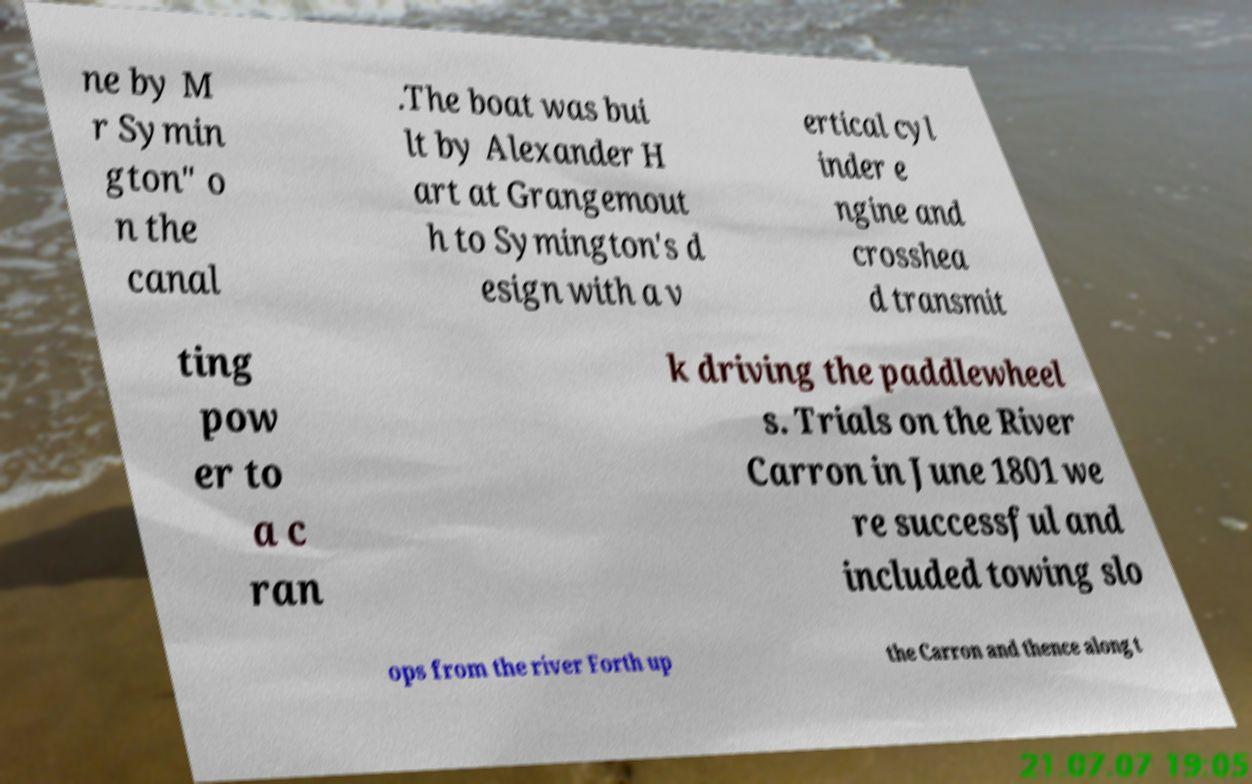What messages or text are displayed in this image? I need them in a readable, typed format. ne by M r Symin gton" o n the canal .The boat was bui lt by Alexander H art at Grangemout h to Symington's d esign with a v ertical cyl inder e ngine and crosshea d transmit ting pow er to a c ran k driving the paddlewheel s. Trials on the River Carron in June 1801 we re successful and included towing slo ops from the river Forth up the Carron and thence along t 